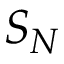Convert formula to latex. <formula><loc_0><loc_0><loc_500><loc_500>S _ { N }</formula> 